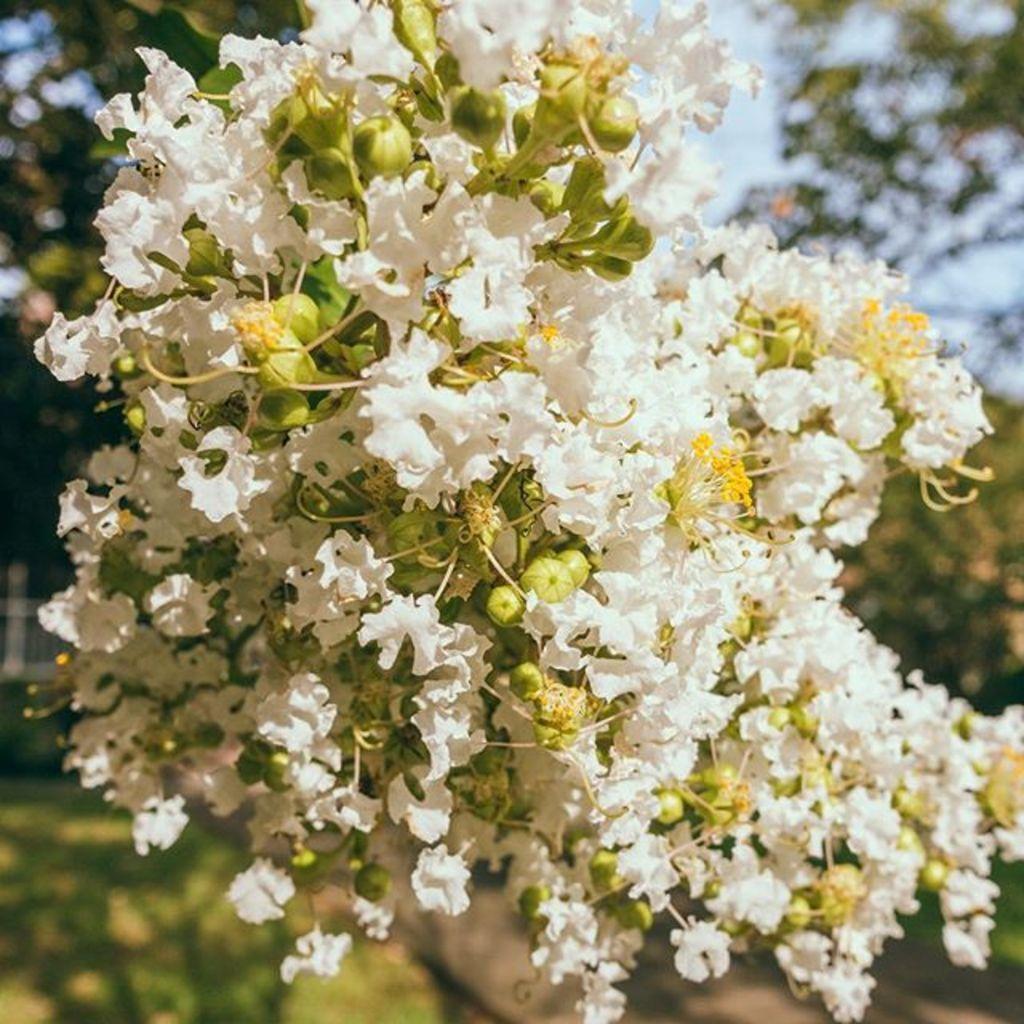Describe this image in one or two sentences. There is a tree, which is having white color flowers. In the background, there are plants and there is a blue sky. 